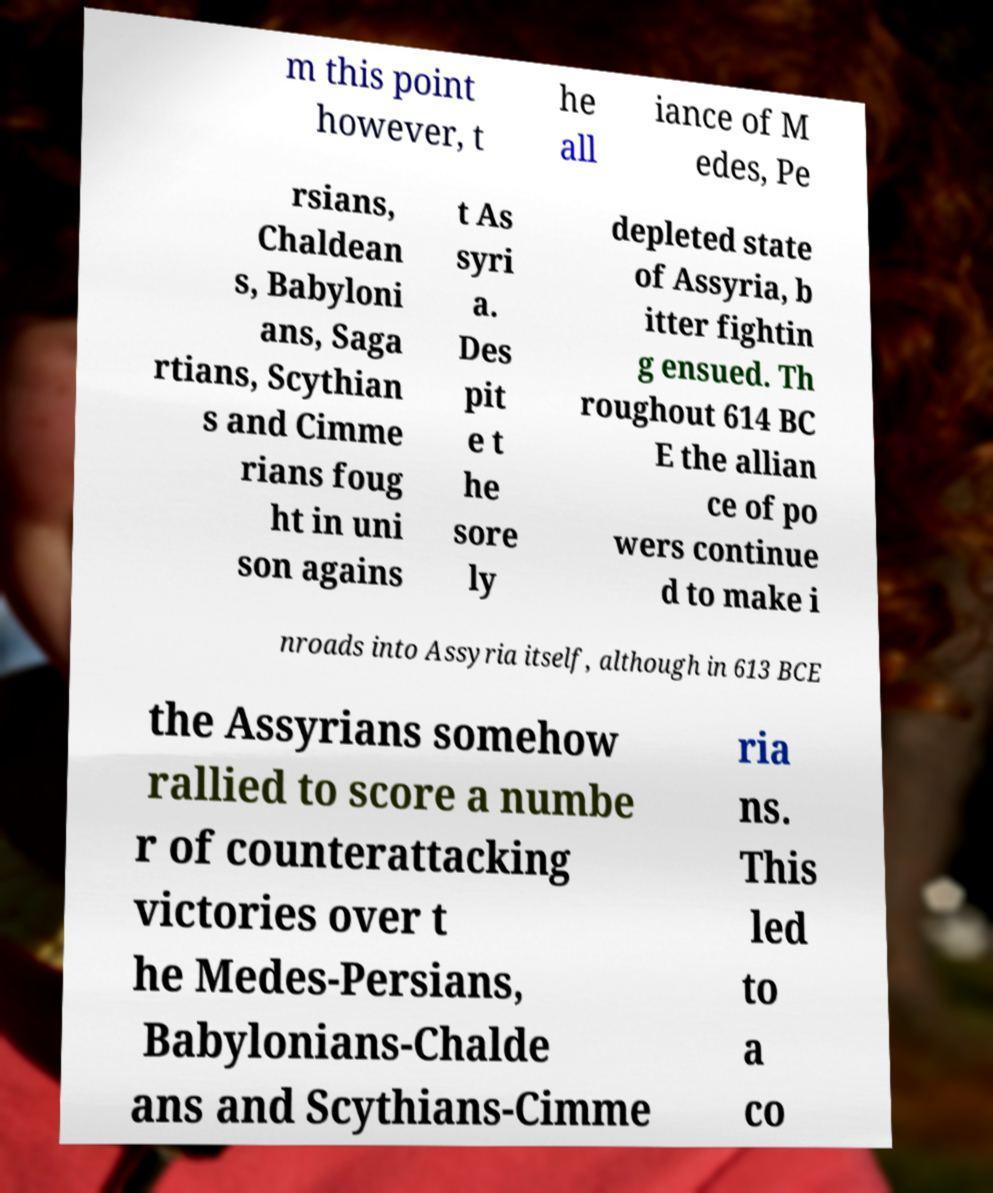Can you accurately transcribe the text from the provided image for me? m this point however, t he all iance of M edes, Pe rsians, Chaldean s, Babyloni ans, Saga rtians, Scythian s and Cimme rians foug ht in uni son agains t As syri a. Des pit e t he sore ly depleted state of Assyria, b itter fightin g ensued. Th roughout 614 BC E the allian ce of po wers continue d to make i nroads into Assyria itself, although in 613 BCE the Assyrians somehow rallied to score a numbe r of counterattacking victories over t he Medes-Persians, Babylonians-Chalde ans and Scythians-Cimme ria ns. This led to a co 